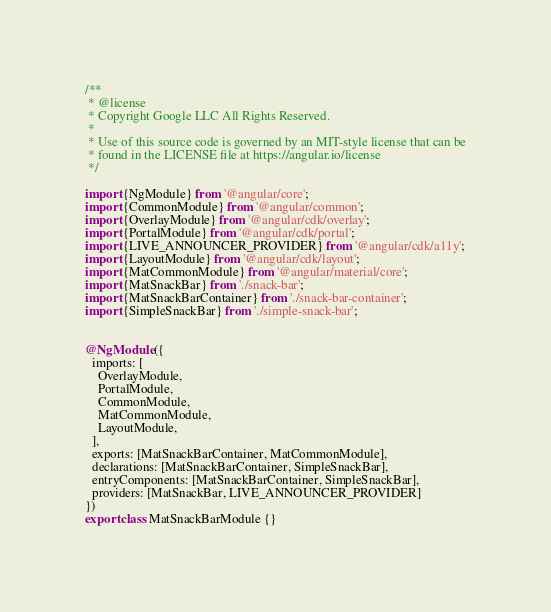<code> <loc_0><loc_0><loc_500><loc_500><_TypeScript_>/**
 * @license
 * Copyright Google LLC All Rights Reserved.
 *
 * Use of this source code is governed by an MIT-style license that can be
 * found in the LICENSE file at https://angular.io/license
 */

import {NgModule} from '@angular/core';
import {CommonModule} from '@angular/common';
import {OverlayModule} from '@angular/cdk/overlay';
import {PortalModule} from '@angular/cdk/portal';
import {LIVE_ANNOUNCER_PROVIDER} from '@angular/cdk/a11y';
import {LayoutModule} from '@angular/cdk/layout';
import {MatCommonModule} from '@angular/material/core';
import {MatSnackBar} from './snack-bar';
import {MatSnackBarContainer} from './snack-bar-container';
import {SimpleSnackBar} from './simple-snack-bar';


@NgModule({
  imports: [
    OverlayModule,
    PortalModule,
    CommonModule,
    MatCommonModule,
    LayoutModule,
  ],
  exports: [MatSnackBarContainer, MatCommonModule],
  declarations: [MatSnackBarContainer, SimpleSnackBar],
  entryComponents: [MatSnackBarContainer, SimpleSnackBar],
  providers: [MatSnackBar, LIVE_ANNOUNCER_PROVIDER]
})
export class MatSnackBarModule {}
</code> 